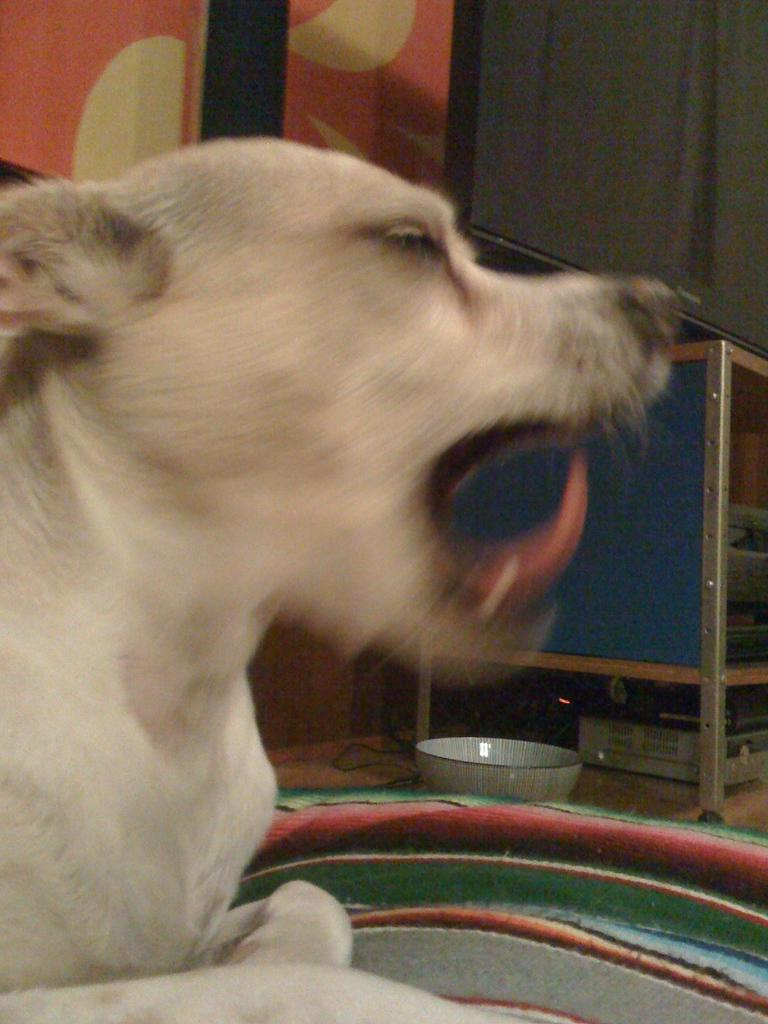What type of animal is in the image? There is a dog in the image, and it is cream-colored. What is located near the dog in the image? There is a bowl in the image. What electronic device can be seen in the image? An electronic gadget is visible in the image. What is on the table in the image? There is a television on a table in the image. What colors are present on the wall in the image? The wall in the image is red and cream-colored. What type of lettuce is being served on the table in the image? There is no lettuce present in the image; the focus is on the dog, bowl, electronic gadget, television, and the wall colors. 